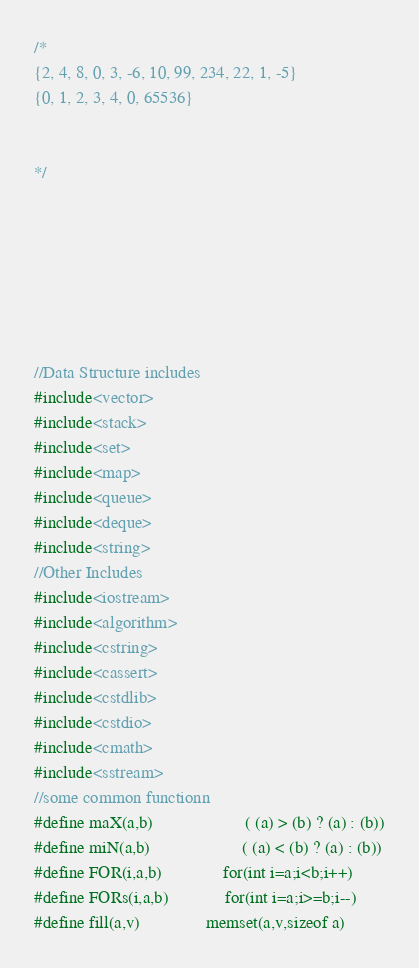Convert code to text. <code><loc_0><loc_0><loc_500><loc_500><_C++_>/*
{2, 4, 8, 0, 3, -6, 10, 99, 234, 22, 1, -5}
{0, 1, 2, 3, 4, 0, 65536}


*/







//Data Structure includes
#include<vector>
#include<stack>
#include<set>
#include<map>
#include<queue>
#include<deque>
#include<string>
//Other Includes
#include<iostream>
#include<algorithm>
#include<cstring>
#include<cassert>
#include<cstdlib>
#include<cstdio>
#include<cmath>
#include<sstream>
//some common functionn
#define maX(a,b)                     ( (a) > (b) ? (a) : (b))
#define miN(a,b)                     ( (a) < (b) ? (a) : (b))
#define FOR(i,a,b)              for(int i=a;i<b;i++)
#define FORs(i,a,b)             for(int i=a;i>=b;i--)
#define fill(a,v)               memset(a,v,sizeof a)</code> 